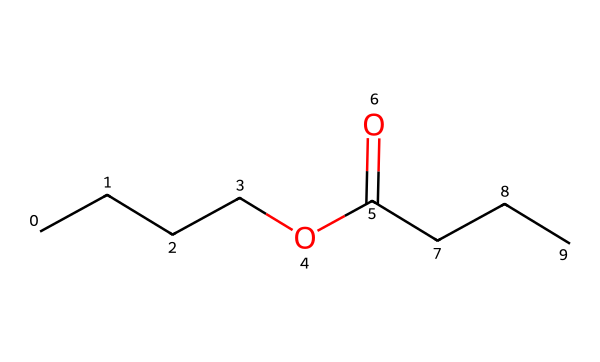What is the molecular formula of butyl butyrate? To determine the molecular formula, we analyze the SMILES representation. The structure represents butyl (C4H9) and butyrate (the butanoate part, C3H5O2 combined with the alkyl part). Summing these, we get C7H14O2 as the complete composition.
Answer: C7H14O2 How many carbon atoms are present in butyl butyrate? In the SMILES notation, we see there are 7 carbon atoms indicated by 'CCCC' and 'CCC'. Counting these gives a total of 7 carbon atoms.
Answer: 7 What type of chemical is butyl butyrate? Analyzing the structure, butyl butyrate is formed from an alcohol (butanol) and an acid (butyric acid), which gives it the classification of an ester due to the presence of the ester functional group (C(=O)O).
Answer: ester What type of functional group is present in butyl butyrate? By examining its structure, the presence of the C(=O)O indicates it has a carboxylic acid-derived functional group, specifically an ester functional group.
Answer: ester How many double bonds are in butyl butyrate? From the SMILES structure, the only double bond present is in the carbonyl part (C=O), so there is one double bond in total, indicating the presence of the ester linkage.
Answer: 1 What is the primary use of butyl butyrate? Butyl butyrate is primarily used as an artificial flavoring agent in food and beverages, particularly to give a fruity flavor, which is especially popular in sports drinks.
Answer: flavoring agent 